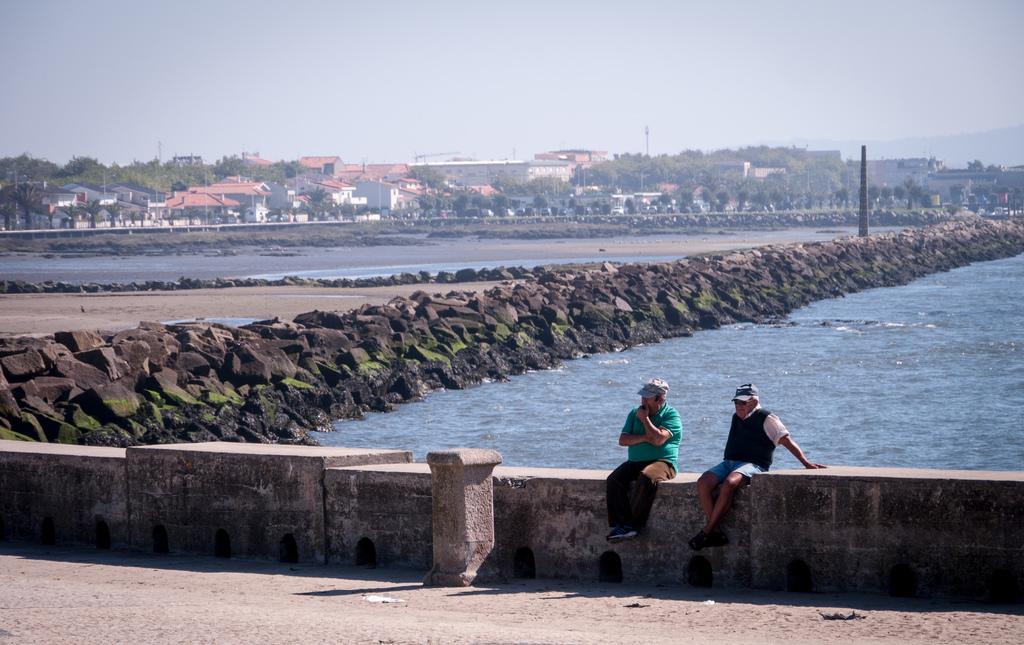In one or two sentences, can you explain what this image depicts? In this image in center there are persons sitting. In the background there is water, there are stones and buildings, trees and poles. 